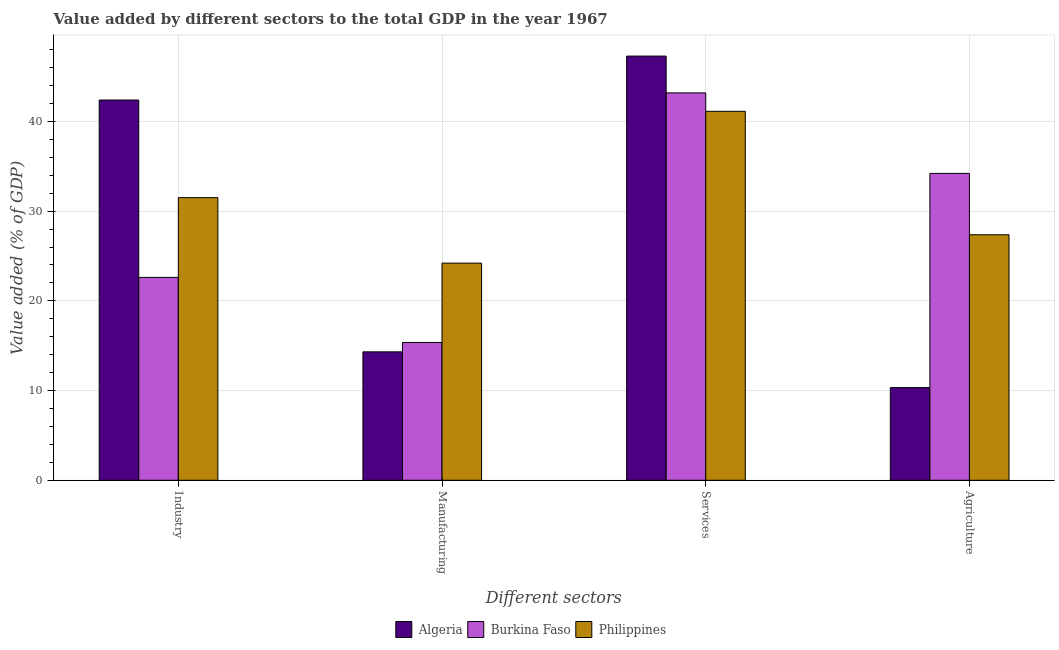How many groups of bars are there?
Your response must be concise. 4. Are the number of bars per tick equal to the number of legend labels?
Provide a succinct answer. Yes. Are the number of bars on each tick of the X-axis equal?
Provide a succinct answer. Yes. How many bars are there on the 4th tick from the left?
Provide a succinct answer. 3. What is the label of the 2nd group of bars from the left?
Your response must be concise. Manufacturing. What is the value added by services sector in Burkina Faso?
Give a very brief answer. 43.18. Across all countries, what is the maximum value added by services sector?
Offer a terse response. 47.28. Across all countries, what is the minimum value added by manufacturing sector?
Offer a very short reply. 14.31. In which country was the value added by agricultural sector maximum?
Your answer should be very brief. Burkina Faso. In which country was the value added by industrial sector minimum?
Your answer should be very brief. Burkina Faso. What is the total value added by services sector in the graph?
Your answer should be compact. 131.59. What is the difference between the value added by services sector in Burkina Faso and that in Philippines?
Your response must be concise. 2.05. What is the difference between the value added by industrial sector in Burkina Faso and the value added by services sector in Algeria?
Provide a short and direct response. -24.67. What is the average value added by agricultural sector per country?
Your answer should be very brief. 23.97. What is the difference between the value added by services sector and value added by agricultural sector in Algeria?
Give a very brief answer. 36.95. What is the ratio of the value added by industrial sector in Algeria to that in Philippines?
Make the answer very short. 1.35. Is the value added by agricultural sector in Algeria less than that in Burkina Faso?
Your answer should be compact. Yes. Is the difference between the value added by services sector in Philippines and Burkina Faso greater than the difference between the value added by industrial sector in Philippines and Burkina Faso?
Offer a very short reply. No. What is the difference between the highest and the second highest value added by services sector?
Ensure brevity in your answer.  4.1. What is the difference between the highest and the lowest value added by manufacturing sector?
Make the answer very short. 9.89. Is it the case that in every country, the sum of the value added by manufacturing sector and value added by agricultural sector is greater than the sum of value added by services sector and value added by industrial sector?
Your answer should be compact. No. What does the 2nd bar from the left in Industry represents?
Give a very brief answer. Burkina Faso. What does the 3rd bar from the right in Manufacturing represents?
Provide a short and direct response. Algeria. Is it the case that in every country, the sum of the value added by industrial sector and value added by manufacturing sector is greater than the value added by services sector?
Give a very brief answer. No. How many bars are there?
Ensure brevity in your answer.  12. Are all the bars in the graph horizontal?
Offer a terse response. No. Does the graph contain grids?
Your answer should be very brief. Yes. Where does the legend appear in the graph?
Give a very brief answer. Bottom center. How are the legend labels stacked?
Your answer should be very brief. Horizontal. What is the title of the graph?
Make the answer very short. Value added by different sectors to the total GDP in the year 1967. What is the label or title of the X-axis?
Provide a succinct answer. Different sectors. What is the label or title of the Y-axis?
Offer a terse response. Value added (% of GDP). What is the Value added (% of GDP) in Algeria in Industry?
Offer a terse response. 42.39. What is the Value added (% of GDP) in Burkina Faso in Industry?
Provide a succinct answer. 22.61. What is the Value added (% of GDP) of Philippines in Industry?
Keep it short and to the point. 31.5. What is the Value added (% of GDP) of Algeria in Manufacturing?
Your answer should be very brief. 14.31. What is the Value added (% of GDP) of Burkina Faso in Manufacturing?
Provide a short and direct response. 15.36. What is the Value added (% of GDP) in Philippines in Manufacturing?
Your answer should be compact. 24.21. What is the Value added (% of GDP) in Algeria in Services?
Your response must be concise. 47.28. What is the Value added (% of GDP) of Burkina Faso in Services?
Provide a short and direct response. 43.18. What is the Value added (% of GDP) in Philippines in Services?
Offer a terse response. 41.13. What is the Value added (% of GDP) in Algeria in Agriculture?
Keep it short and to the point. 10.33. What is the Value added (% of GDP) in Burkina Faso in Agriculture?
Offer a very short reply. 34.21. What is the Value added (% of GDP) of Philippines in Agriculture?
Provide a short and direct response. 27.37. Across all Different sectors, what is the maximum Value added (% of GDP) of Algeria?
Your answer should be compact. 47.28. Across all Different sectors, what is the maximum Value added (% of GDP) of Burkina Faso?
Ensure brevity in your answer.  43.18. Across all Different sectors, what is the maximum Value added (% of GDP) in Philippines?
Offer a terse response. 41.13. Across all Different sectors, what is the minimum Value added (% of GDP) of Algeria?
Provide a succinct answer. 10.33. Across all Different sectors, what is the minimum Value added (% of GDP) of Burkina Faso?
Your response must be concise. 15.36. Across all Different sectors, what is the minimum Value added (% of GDP) of Philippines?
Your answer should be compact. 24.21. What is the total Value added (% of GDP) in Algeria in the graph?
Ensure brevity in your answer.  114.31. What is the total Value added (% of GDP) of Burkina Faso in the graph?
Provide a short and direct response. 115.36. What is the total Value added (% of GDP) in Philippines in the graph?
Provide a short and direct response. 124.21. What is the difference between the Value added (% of GDP) of Algeria in Industry and that in Manufacturing?
Offer a terse response. 28.07. What is the difference between the Value added (% of GDP) of Burkina Faso in Industry and that in Manufacturing?
Keep it short and to the point. 7.25. What is the difference between the Value added (% of GDP) in Philippines in Industry and that in Manufacturing?
Give a very brief answer. 7.3. What is the difference between the Value added (% of GDP) of Algeria in Industry and that in Services?
Your answer should be very brief. -4.9. What is the difference between the Value added (% of GDP) of Burkina Faso in Industry and that in Services?
Provide a succinct answer. -20.57. What is the difference between the Value added (% of GDP) in Philippines in Industry and that in Services?
Give a very brief answer. -9.62. What is the difference between the Value added (% of GDP) in Algeria in Industry and that in Agriculture?
Offer a very short reply. 32.06. What is the difference between the Value added (% of GDP) in Burkina Faso in Industry and that in Agriculture?
Provide a short and direct response. -11.59. What is the difference between the Value added (% of GDP) in Philippines in Industry and that in Agriculture?
Provide a short and direct response. 4.14. What is the difference between the Value added (% of GDP) in Algeria in Manufacturing and that in Services?
Your answer should be compact. -32.97. What is the difference between the Value added (% of GDP) of Burkina Faso in Manufacturing and that in Services?
Provide a succinct answer. -27.82. What is the difference between the Value added (% of GDP) of Philippines in Manufacturing and that in Services?
Provide a short and direct response. -16.92. What is the difference between the Value added (% of GDP) in Algeria in Manufacturing and that in Agriculture?
Provide a short and direct response. 3.98. What is the difference between the Value added (% of GDP) in Burkina Faso in Manufacturing and that in Agriculture?
Provide a succinct answer. -18.85. What is the difference between the Value added (% of GDP) in Philippines in Manufacturing and that in Agriculture?
Offer a very short reply. -3.16. What is the difference between the Value added (% of GDP) of Algeria in Services and that in Agriculture?
Your response must be concise. 36.95. What is the difference between the Value added (% of GDP) in Burkina Faso in Services and that in Agriculture?
Offer a very short reply. 8.97. What is the difference between the Value added (% of GDP) of Philippines in Services and that in Agriculture?
Your answer should be compact. 13.76. What is the difference between the Value added (% of GDP) of Algeria in Industry and the Value added (% of GDP) of Burkina Faso in Manufacturing?
Make the answer very short. 27.03. What is the difference between the Value added (% of GDP) in Algeria in Industry and the Value added (% of GDP) in Philippines in Manufacturing?
Your response must be concise. 18.18. What is the difference between the Value added (% of GDP) in Burkina Faso in Industry and the Value added (% of GDP) in Philippines in Manufacturing?
Offer a very short reply. -1.59. What is the difference between the Value added (% of GDP) in Algeria in Industry and the Value added (% of GDP) in Burkina Faso in Services?
Offer a terse response. -0.79. What is the difference between the Value added (% of GDP) in Algeria in Industry and the Value added (% of GDP) in Philippines in Services?
Offer a very short reply. 1.26. What is the difference between the Value added (% of GDP) of Burkina Faso in Industry and the Value added (% of GDP) of Philippines in Services?
Offer a very short reply. -18.51. What is the difference between the Value added (% of GDP) of Algeria in Industry and the Value added (% of GDP) of Burkina Faso in Agriculture?
Your answer should be compact. 8.18. What is the difference between the Value added (% of GDP) in Algeria in Industry and the Value added (% of GDP) in Philippines in Agriculture?
Offer a very short reply. 15.02. What is the difference between the Value added (% of GDP) of Burkina Faso in Industry and the Value added (% of GDP) of Philippines in Agriculture?
Keep it short and to the point. -4.75. What is the difference between the Value added (% of GDP) of Algeria in Manufacturing and the Value added (% of GDP) of Burkina Faso in Services?
Offer a terse response. -28.86. What is the difference between the Value added (% of GDP) of Algeria in Manufacturing and the Value added (% of GDP) of Philippines in Services?
Offer a terse response. -26.81. What is the difference between the Value added (% of GDP) of Burkina Faso in Manufacturing and the Value added (% of GDP) of Philippines in Services?
Provide a short and direct response. -25.77. What is the difference between the Value added (% of GDP) of Algeria in Manufacturing and the Value added (% of GDP) of Burkina Faso in Agriculture?
Give a very brief answer. -19.89. What is the difference between the Value added (% of GDP) in Algeria in Manufacturing and the Value added (% of GDP) in Philippines in Agriculture?
Provide a succinct answer. -13.05. What is the difference between the Value added (% of GDP) of Burkina Faso in Manufacturing and the Value added (% of GDP) of Philippines in Agriculture?
Your answer should be compact. -12.01. What is the difference between the Value added (% of GDP) in Algeria in Services and the Value added (% of GDP) in Burkina Faso in Agriculture?
Offer a very short reply. 13.08. What is the difference between the Value added (% of GDP) of Algeria in Services and the Value added (% of GDP) of Philippines in Agriculture?
Offer a very short reply. 19.92. What is the difference between the Value added (% of GDP) in Burkina Faso in Services and the Value added (% of GDP) in Philippines in Agriculture?
Make the answer very short. 15.81. What is the average Value added (% of GDP) of Algeria per Different sectors?
Give a very brief answer. 28.58. What is the average Value added (% of GDP) in Burkina Faso per Different sectors?
Offer a terse response. 28.84. What is the average Value added (% of GDP) of Philippines per Different sectors?
Ensure brevity in your answer.  31.05. What is the difference between the Value added (% of GDP) in Algeria and Value added (% of GDP) in Burkina Faso in Industry?
Your answer should be very brief. 19.77. What is the difference between the Value added (% of GDP) in Algeria and Value added (% of GDP) in Philippines in Industry?
Provide a short and direct response. 10.88. What is the difference between the Value added (% of GDP) in Burkina Faso and Value added (% of GDP) in Philippines in Industry?
Your answer should be compact. -8.89. What is the difference between the Value added (% of GDP) in Algeria and Value added (% of GDP) in Burkina Faso in Manufacturing?
Your answer should be compact. -1.05. What is the difference between the Value added (% of GDP) of Algeria and Value added (% of GDP) of Philippines in Manufacturing?
Make the answer very short. -9.89. What is the difference between the Value added (% of GDP) in Burkina Faso and Value added (% of GDP) in Philippines in Manufacturing?
Offer a very short reply. -8.85. What is the difference between the Value added (% of GDP) in Algeria and Value added (% of GDP) in Burkina Faso in Services?
Your answer should be compact. 4.1. What is the difference between the Value added (% of GDP) of Algeria and Value added (% of GDP) of Philippines in Services?
Your answer should be very brief. 6.16. What is the difference between the Value added (% of GDP) of Burkina Faso and Value added (% of GDP) of Philippines in Services?
Make the answer very short. 2.05. What is the difference between the Value added (% of GDP) in Algeria and Value added (% of GDP) in Burkina Faso in Agriculture?
Make the answer very short. -23.88. What is the difference between the Value added (% of GDP) of Algeria and Value added (% of GDP) of Philippines in Agriculture?
Keep it short and to the point. -17.04. What is the difference between the Value added (% of GDP) of Burkina Faso and Value added (% of GDP) of Philippines in Agriculture?
Offer a very short reply. 6.84. What is the ratio of the Value added (% of GDP) in Algeria in Industry to that in Manufacturing?
Make the answer very short. 2.96. What is the ratio of the Value added (% of GDP) of Burkina Faso in Industry to that in Manufacturing?
Your answer should be compact. 1.47. What is the ratio of the Value added (% of GDP) of Philippines in Industry to that in Manufacturing?
Ensure brevity in your answer.  1.3. What is the ratio of the Value added (% of GDP) of Algeria in Industry to that in Services?
Provide a short and direct response. 0.9. What is the ratio of the Value added (% of GDP) of Burkina Faso in Industry to that in Services?
Offer a very short reply. 0.52. What is the ratio of the Value added (% of GDP) in Philippines in Industry to that in Services?
Make the answer very short. 0.77. What is the ratio of the Value added (% of GDP) of Algeria in Industry to that in Agriculture?
Offer a terse response. 4.1. What is the ratio of the Value added (% of GDP) of Burkina Faso in Industry to that in Agriculture?
Your response must be concise. 0.66. What is the ratio of the Value added (% of GDP) of Philippines in Industry to that in Agriculture?
Your answer should be compact. 1.15. What is the ratio of the Value added (% of GDP) in Algeria in Manufacturing to that in Services?
Offer a very short reply. 0.3. What is the ratio of the Value added (% of GDP) of Burkina Faso in Manufacturing to that in Services?
Your response must be concise. 0.36. What is the ratio of the Value added (% of GDP) of Philippines in Manufacturing to that in Services?
Keep it short and to the point. 0.59. What is the ratio of the Value added (% of GDP) in Algeria in Manufacturing to that in Agriculture?
Make the answer very short. 1.39. What is the ratio of the Value added (% of GDP) in Burkina Faso in Manufacturing to that in Agriculture?
Your response must be concise. 0.45. What is the ratio of the Value added (% of GDP) in Philippines in Manufacturing to that in Agriculture?
Keep it short and to the point. 0.88. What is the ratio of the Value added (% of GDP) in Algeria in Services to that in Agriculture?
Give a very brief answer. 4.58. What is the ratio of the Value added (% of GDP) of Burkina Faso in Services to that in Agriculture?
Provide a short and direct response. 1.26. What is the ratio of the Value added (% of GDP) in Philippines in Services to that in Agriculture?
Ensure brevity in your answer.  1.5. What is the difference between the highest and the second highest Value added (% of GDP) in Algeria?
Your response must be concise. 4.9. What is the difference between the highest and the second highest Value added (% of GDP) of Burkina Faso?
Provide a short and direct response. 8.97. What is the difference between the highest and the second highest Value added (% of GDP) in Philippines?
Your answer should be very brief. 9.62. What is the difference between the highest and the lowest Value added (% of GDP) of Algeria?
Give a very brief answer. 36.95. What is the difference between the highest and the lowest Value added (% of GDP) in Burkina Faso?
Your answer should be very brief. 27.82. What is the difference between the highest and the lowest Value added (% of GDP) of Philippines?
Your answer should be very brief. 16.92. 